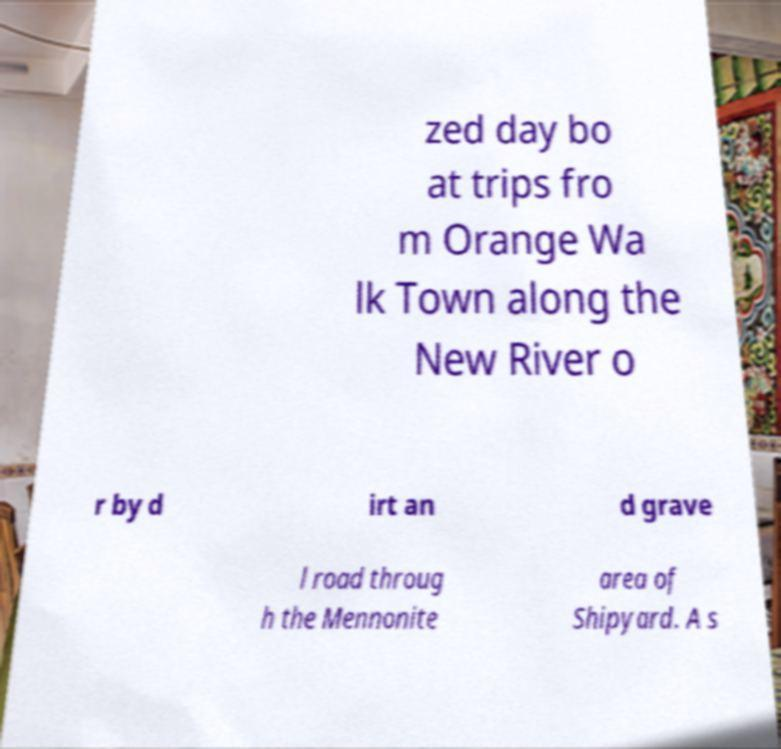Please read and relay the text visible in this image. What does it say? zed day bo at trips fro m Orange Wa lk Town along the New River o r by d irt an d grave l road throug h the Mennonite area of Shipyard. A s 